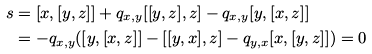Convert formula to latex. <formula><loc_0><loc_0><loc_500><loc_500>s & = [ x , [ y , z ] ] + q _ { x , y } [ [ y , z ] , z ] - q _ { x , y } [ y , [ x , z ] ] \\ & = - q _ { x , y } ( [ y , [ x , z ] ] - [ [ y , x ] , z ] - q _ { y , x } [ x , [ y , z ] ] ) = 0</formula> 